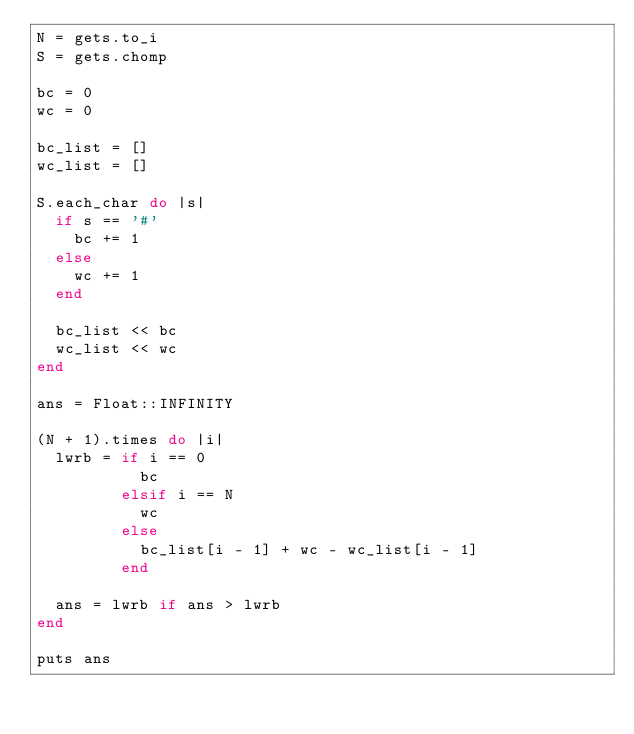Convert code to text. <code><loc_0><loc_0><loc_500><loc_500><_Ruby_>N = gets.to_i
S = gets.chomp

bc = 0
wc = 0

bc_list = []
wc_list = []

S.each_char do |s|
  if s == '#'
    bc += 1
  else
    wc += 1
  end

  bc_list << bc
  wc_list << wc
end

ans = Float::INFINITY

(N + 1).times do |i|
  lwrb = if i == 0
           bc
         elsif i == N
           wc
         else
           bc_list[i - 1] + wc - wc_list[i - 1]
         end

  ans = lwrb if ans > lwrb
end

puts ans
</code> 